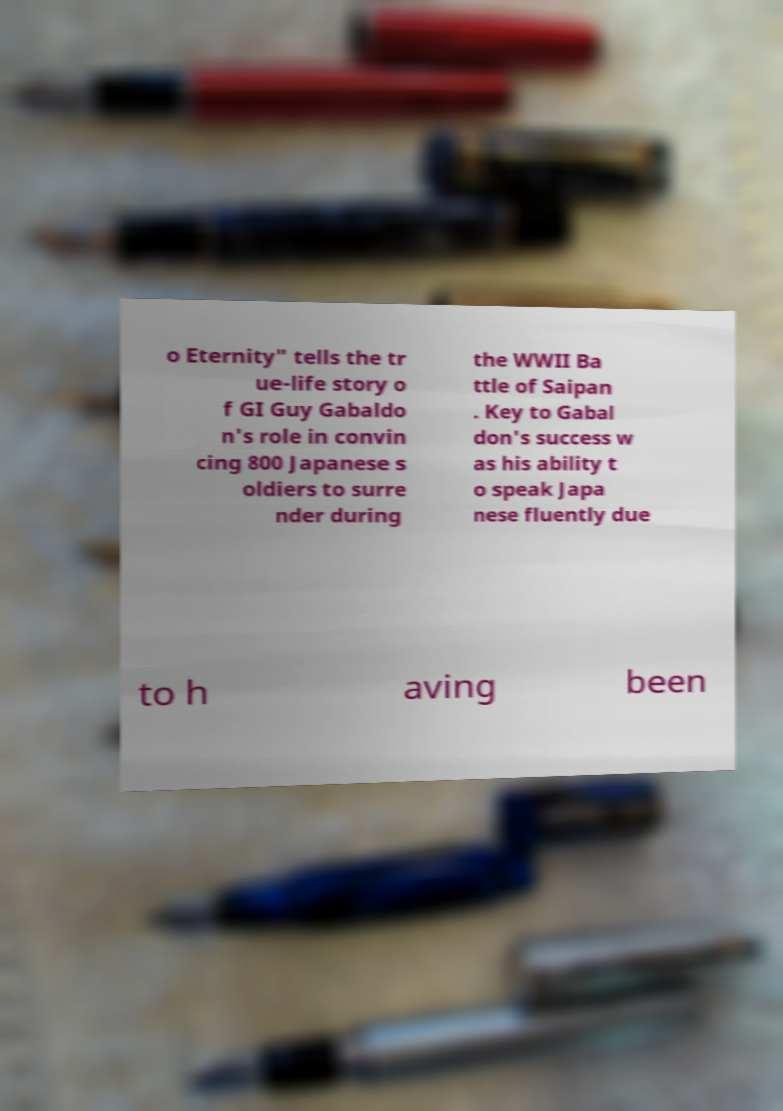I need the written content from this picture converted into text. Can you do that? o Eternity" tells the tr ue-life story o f GI Guy Gabaldo n's role in convin cing 800 Japanese s oldiers to surre nder during the WWII Ba ttle of Saipan . Key to Gabal don's success w as his ability t o speak Japa nese fluently due to h aving been 